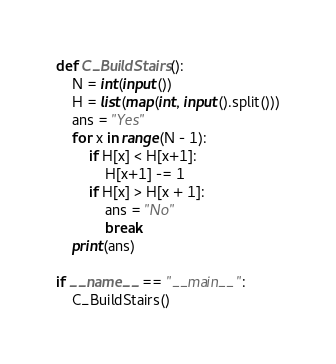<code> <loc_0><loc_0><loc_500><loc_500><_Python_>def C_BuildStairs():
    N = int(input())
    H = list(map(int, input().split()))
    ans = "Yes"
    for x in range(N - 1):
        if H[x] < H[x+1]:
            H[x+1] -= 1
        if H[x] > H[x + 1]:
            ans = "No"
            break
    print(ans)
    
if __name__ == "__main__":
    C_BuildStairs()</code> 